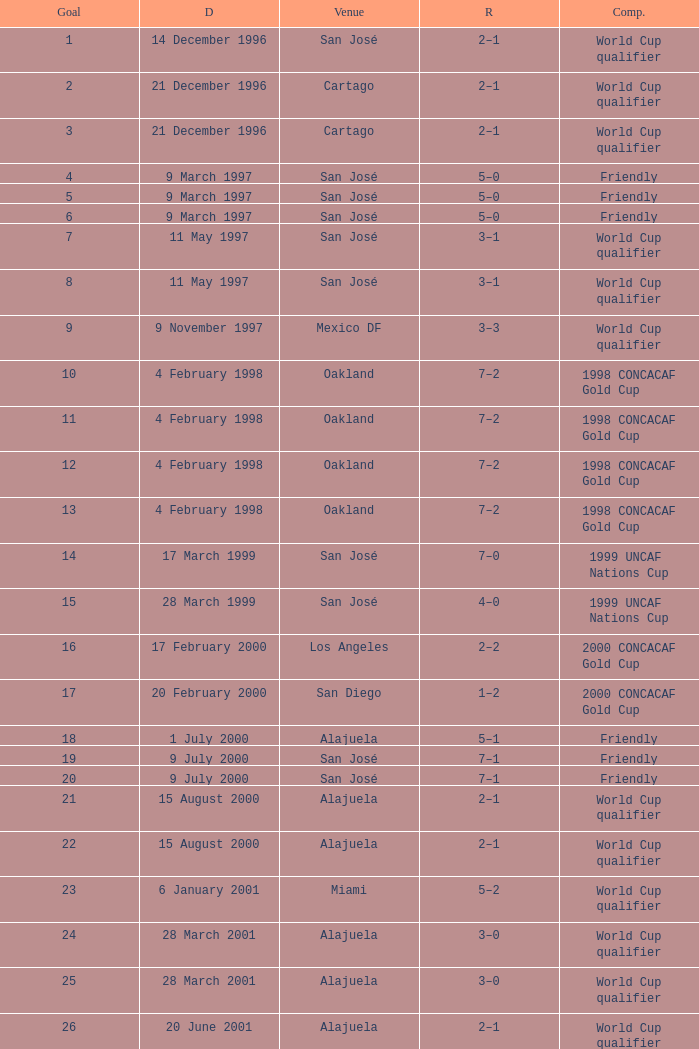What is the result in oakland? 7–2, 7–2, 7–2, 7–2. 